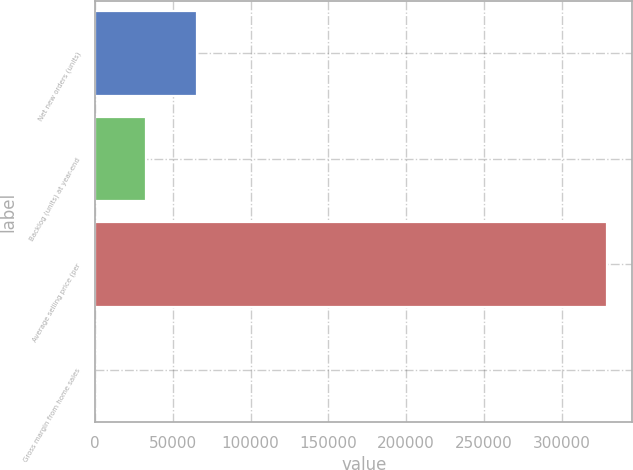<chart> <loc_0><loc_0><loc_500><loc_500><bar_chart><fcel>Net new orders (units)<fcel>Backlog (units) at year-end<fcel>Average selling price (per<fcel>Gross margin from home sales<nl><fcel>65818.6<fcel>32921<fcel>329000<fcel>23.3<nl></chart> 